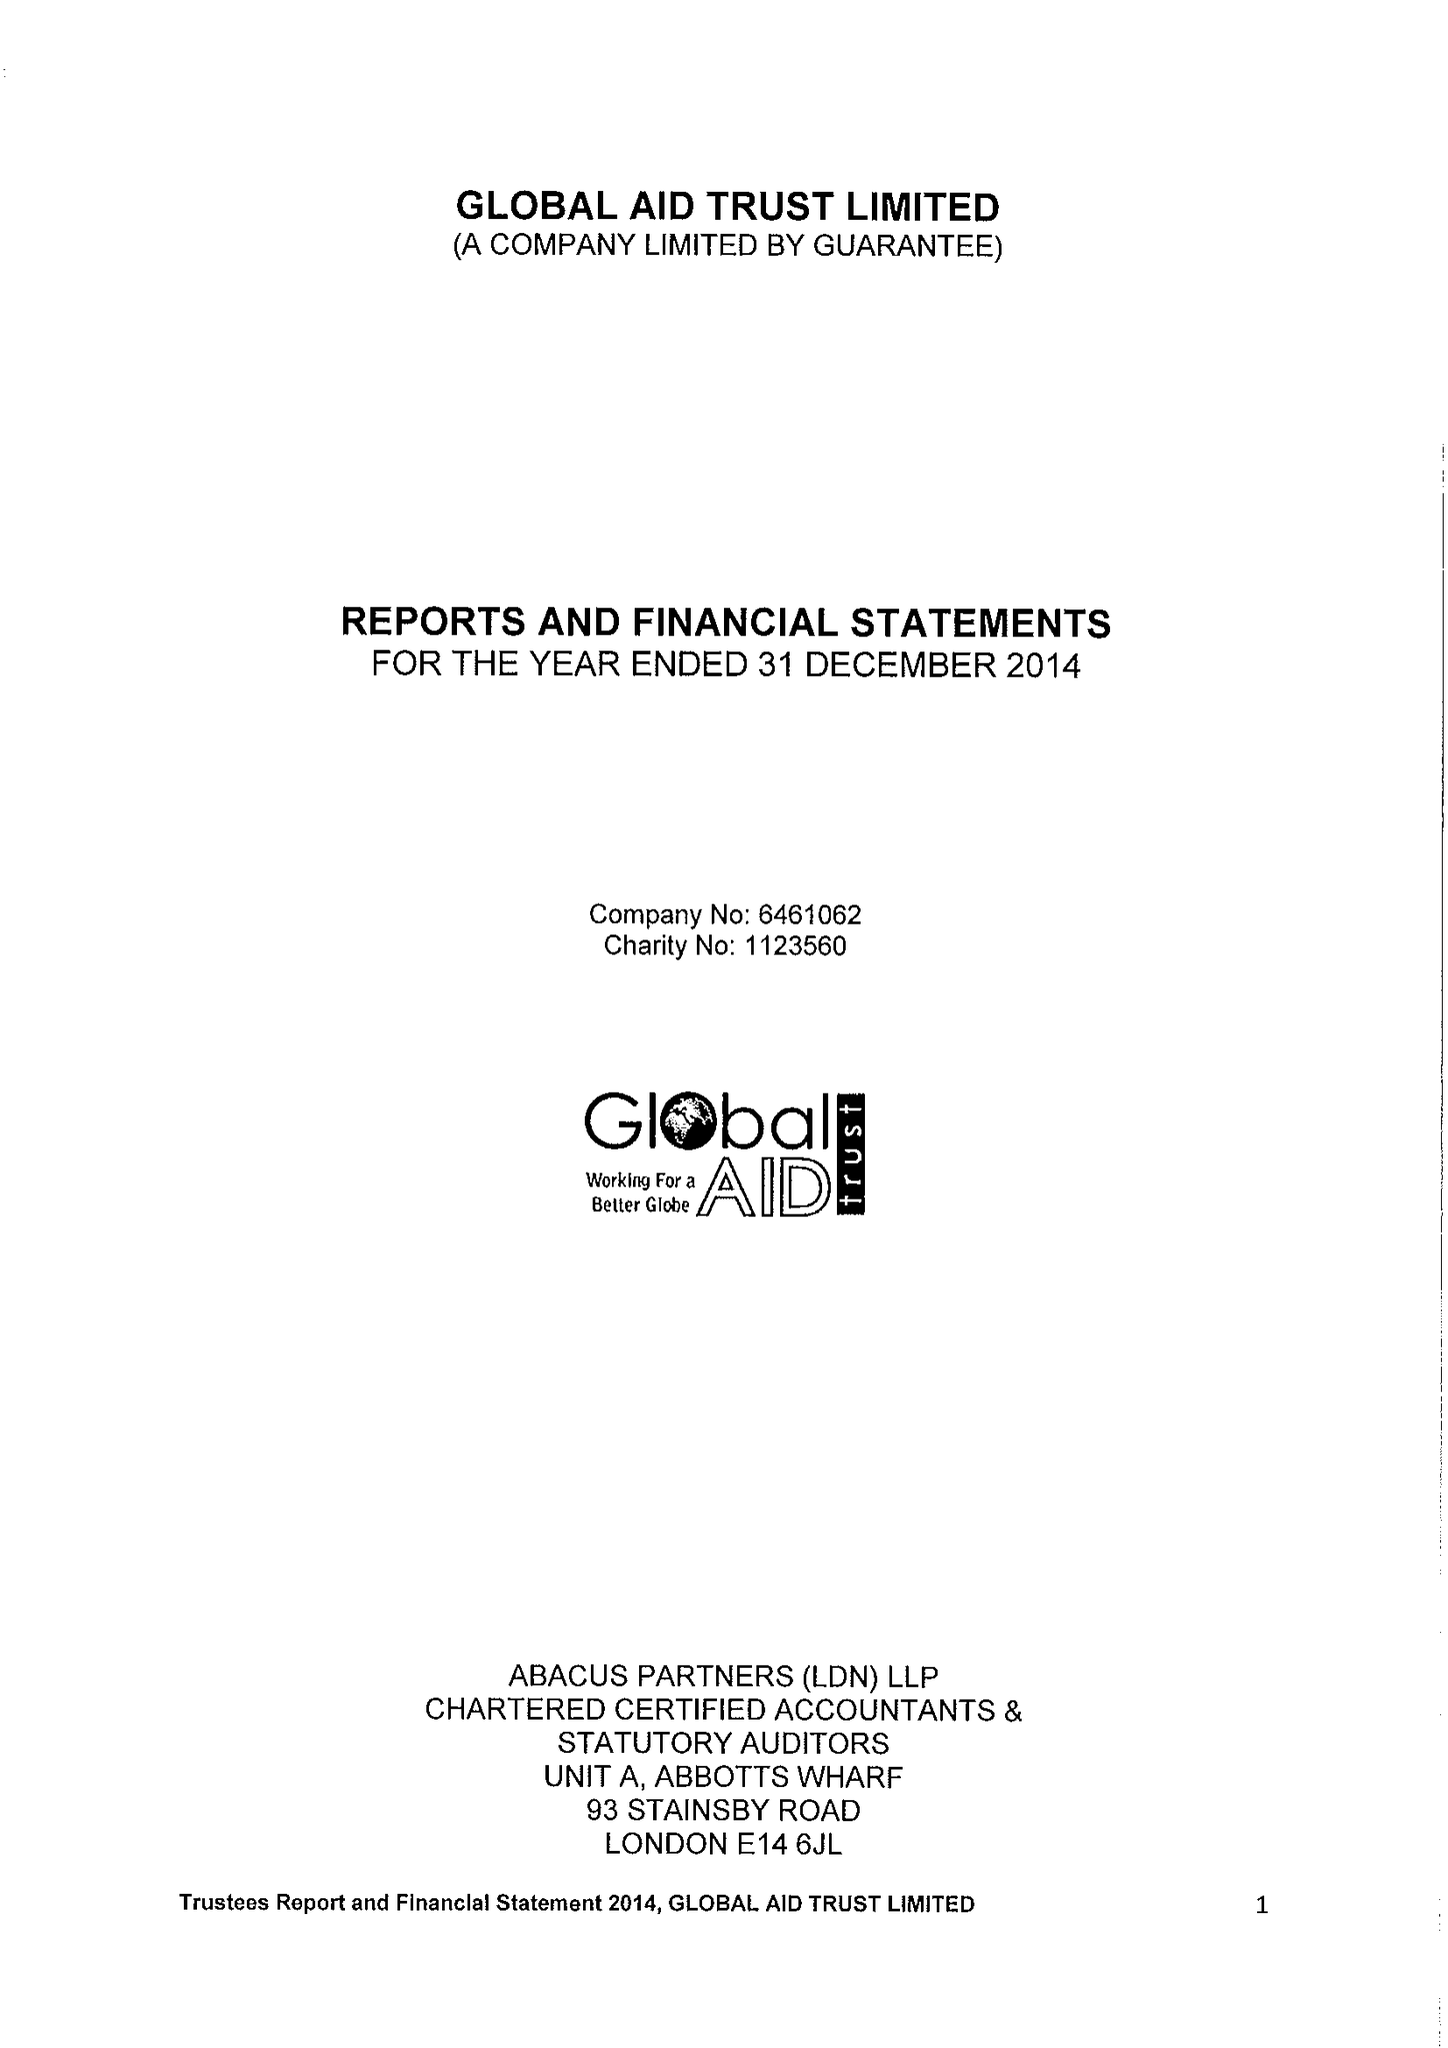What is the value for the report_date?
Answer the question using a single word or phrase. 2014-12-31 